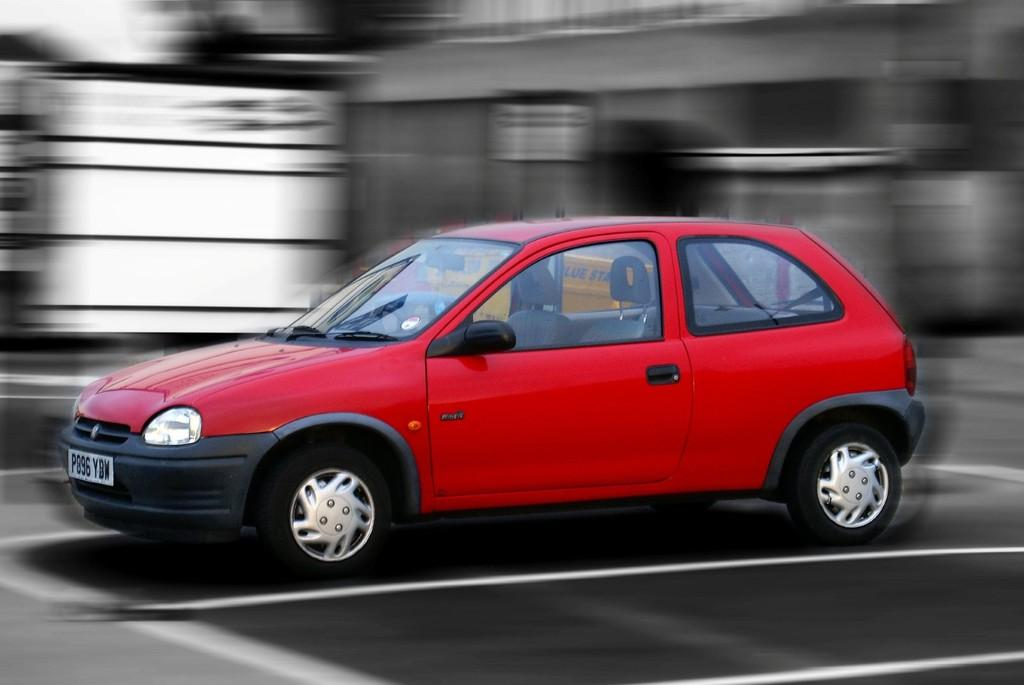What color is the car that is visible in the image? There is a red color car in the image. Where is the car located in the image? The car is on the road in the image. Can you describe the background of the image? The background of the image is blurred. What type of cheese can be seen being sold at the market in the image? There is no market or cheese present in the image; it features a red color car on the road with a blurred background. What type of trail can be seen leading to the car in the image? There is no trail present in the image; it features a red color car on the road with a blurred background. 